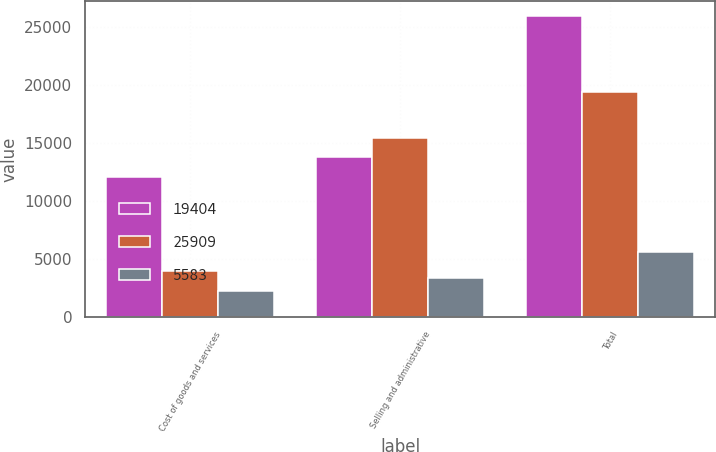<chart> <loc_0><loc_0><loc_500><loc_500><stacked_bar_chart><ecel><fcel>Cost of goods and services<fcel>Selling and administrative<fcel>Total<nl><fcel>19404<fcel>12098<fcel>13811<fcel>25909<nl><fcel>25909<fcel>3935<fcel>15469<fcel>19404<nl><fcel>5583<fcel>2243<fcel>3340<fcel>5583<nl></chart> 